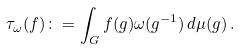<formula> <loc_0><loc_0><loc_500><loc_500>\tau _ { \omega } ( f ) \colon = \int _ { G } f ( g ) \omega ( g ^ { - 1 } ) \, d \mu ( g ) \, .</formula> 